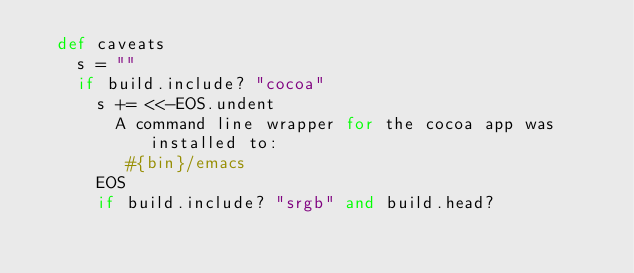Convert code to text. <code><loc_0><loc_0><loc_500><loc_500><_Ruby_>  def caveats
    s = ""
    if build.include? "cocoa"
      s += <<-EOS.undent
        A command line wrapper for the cocoa app was installed to:
         #{bin}/emacs
      EOS
      if build.include? "srgb" and build.head?</code> 